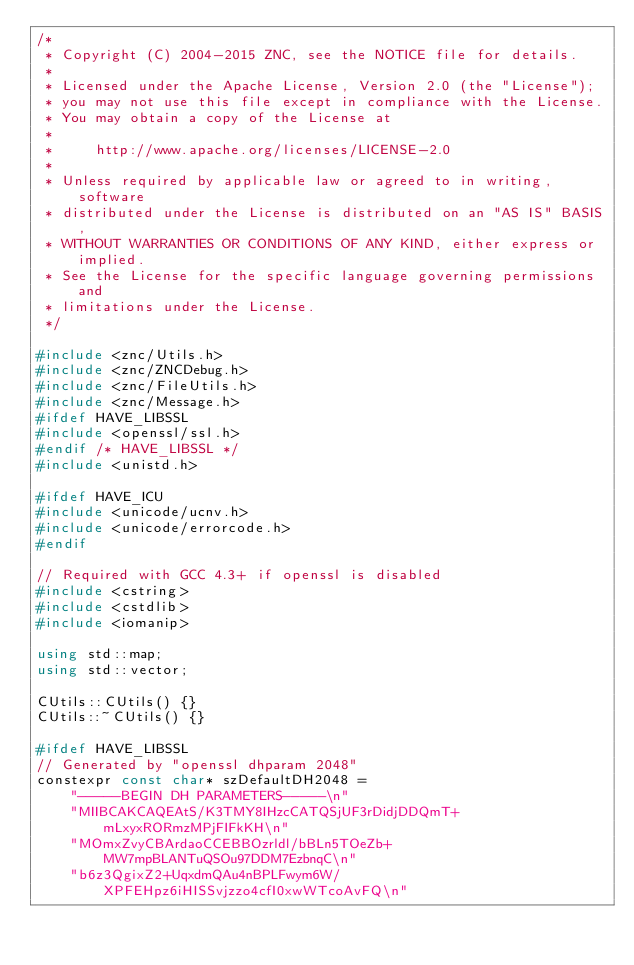<code> <loc_0><loc_0><loc_500><loc_500><_C++_>/*
 * Copyright (C) 2004-2015 ZNC, see the NOTICE file for details.
 *
 * Licensed under the Apache License, Version 2.0 (the "License");
 * you may not use this file except in compliance with the License.
 * You may obtain a copy of the License at
 *
 *     http://www.apache.org/licenses/LICENSE-2.0
 *
 * Unless required by applicable law or agreed to in writing, software
 * distributed under the License is distributed on an "AS IS" BASIS,
 * WITHOUT WARRANTIES OR CONDITIONS OF ANY KIND, either express or implied.
 * See the License for the specific language governing permissions and
 * limitations under the License.
 */

#include <znc/Utils.h>
#include <znc/ZNCDebug.h>
#include <znc/FileUtils.h>
#include <znc/Message.h>
#ifdef HAVE_LIBSSL
#include <openssl/ssl.h>
#endif /* HAVE_LIBSSL */
#include <unistd.h>

#ifdef HAVE_ICU
#include <unicode/ucnv.h>
#include <unicode/errorcode.h>
#endif

// Required with GCC 4.3+ if openssl is disabled
#include <cstring>
#include <cstdlib>
#include <iomanip>

using std::map;
using std::vector;

CUtils::CUtils() {}
CUtils::~CUtils() {}

#ifdef HAVE_LIBSSL
// Generated by "openssl dhparam 2048"
constexpr const char* szDefaultDH2048 =
	"-----BEGIN DH PARAMETERS-----\n"
	"MIIBCAKCAQEAtS/K3TMY8IHzcCATQSjUF3rDidjDDQmT+mLxyxRORmzMPjFIFkKH\n"
	"MOmxZvyCBArdaoCCEBBOzrldl/bBLn5TOeZb+MW7mpBLANTuQSOu97DDM7EzbnqC\n"
	"b6z3QgixZ2+UqxdmQAu4nBPLFwym6W/XPFEHpz6iHISSvjzzo4cfI0xwWTcoAvFQ\n"</code> 